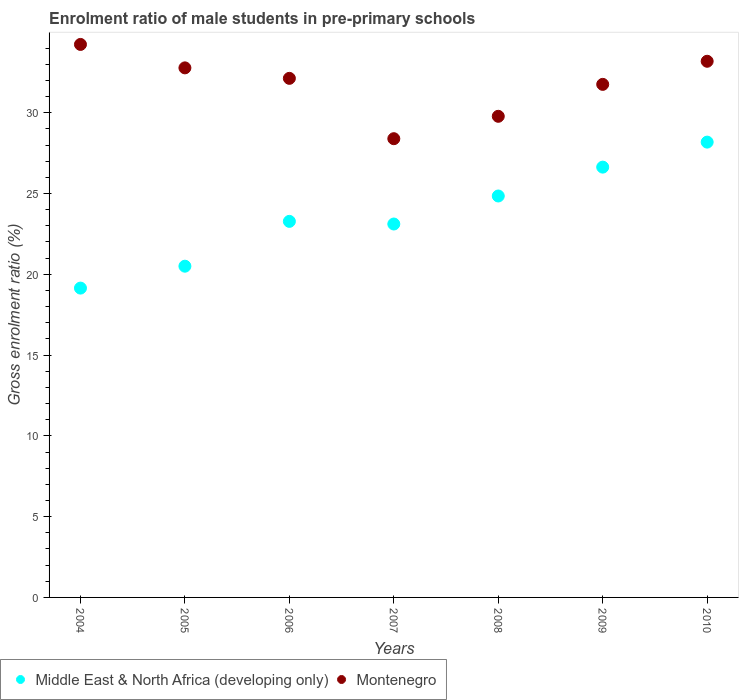How many different coloured dotlines are there?
Provide a short and direct response. 2. What is the enrolment ratio of male students in pre-primary schools in Montenegro in 2006?
Give a very brief answer. 32.13. Across all years, what is the maximum enrolment ratio of male students in pre-primary schools in Middle East & North Africa (developing only)?
Provide a short and direct response. 28.18. Across all years, what is the minimum enrolment ratio of male students in pre-primary schools in Middle East & North Africa (developing only)?
Your answer should be compact. 19.15. What is the total enrolment ratio of male students in pre-primary schools in Montenegro in the graph?
Your answer should be very brief. 222.25. What is the difference between the enrolment ratio of male students in pre-primary schools in Middle East & North Africa (developing only) in 2005 and that in 2009?
Make the answer very short. -6.13. What is the difference between the enrolment ratio of male students in pre-primary schools in Montenegro in 2007 and the enrolment ratio of male students in pre-primary schools in Middle East & North Africa (developing only) in 2010?
Give a very brief answer. 0.21. What is the average enrolment ratio of male students in pre-primary schools in Montenegro per year?
Offer a very short reply. 31.75. In the year 2009, what is the difference between the enrolment ratio of male students in pre-primary schools in Montenegro and enrolment ratio of male students in pre-primary schools in Middle East & North Africa (developing only)?
Offer a very short reply. 5.12. In how many years, is the enrolment ratio of male students in pre-primary schools in Montenegro greater than 27 %?
Offer a very short reply. 7. What is the ratio of the enrolment ratio of male students in pre-primary schools in Montenegro in 2005 to that in 2010?
Offer a terse response. 0.99. What is the difference between the highest and the second highest enrolment ratio of male students in pre-primary schools in Montenegro?
Make the answer very short. 1.04. What is the difference between the highest and the lowest enrolment ratio of male students in pre-primary schools in Middle East & North Africa (developing only)?
Offer a terse response. 9.04. In how many years, is the enrolment ratio of male students in pre-primary schools in Middle East & North Africa (developing only) greater than the average enrolment ratio of male students in pre-primary schools in Middle East & North Africa (developing only) taken over all years?
Your answer should be very brief. 3. Is the sum of the enrolment ratio of male students in pre-primary schools in Montenegro in 2005 and 2006 greater than the maximum enrolment ratio of male students in pre-primary schools in Middle East & North Africa (developing only) across all years?
Offer a terse response. Yes. Does the enrolment ratio of male students in pre-primary schools in Middle East & North Africa (developing only) monotonically increase over the years?
Provide a short and direct response. No. Is the enrolment ratio of male students in pre-primary schools in Montenegro strictly greater than the enrolment ratio of male students in pre-primary schools in Middle East & North Africa (developing only) over the years?
Offer a terse response. Yes. How many dotlines are there?
Your response must be concise. 2. How many years are there in the graph?
Give a very brief answer. 7. What is the difference between two consecutive major ticks on the Y-axis?
Make the answer very short. 5. Are the values on the major ticks of Y-axis written in scientific E-notation?
Give a very brief answer. No. Where does the legend appear in the graph?
Your response must be concise. Bottom left. How many legend labels are there?
Keep it short and to the point. 2. What is the title of the graph?
Provide a short and direct response. Enrolment ratio of male students in pre-primary schools. Does "China" appear as one of the legend labels in the graph?
Ensure brevity in your answer.  No. What is the label or title of the X-axis?
Ensure brevity in your answer.  Years. What is the label or title of the Y-axis?
Offer a very short reply. Gross enrolment ratio (%). What is the Gross enrolment ratio (%) of Middle East & North Africa (developing only) in 2004?
Make the answer very short. 19.15. What is the Gross enrolment ratio (%) in Montenegro in 2004?
Your response must be concise. 34.23. What is the Gross enrolment ratio (%) of Middle East & North Africa (developing only) in 2005?
Give a very brief answer. 20.5. What is the Gross enrolment ratio (%) of Montenegro in 2005?
Your answer should be compact. 32.78. What is the Gross enrolment ratio (%) in Middle East & North Africa (developing only) in 2006?
Provide a short and direct response. 23.28. What is the Gross enrolment ratio (%) in Montenegro in 2006?
Ensure brevity in your answer.  32.13. What is the Gross enrolment ratio (%) of Middle East & North Africa (developing only) in 2007?
Ensure brevity in your answer.  23.11. What is the Gross enrolment ratio (%) in Montenegro in 2007?
Keep it short and to the point. 28.39. What is the Gross enrolment ratio (%) of Middle East & North Africa (developing only) in 2008?
Ensure brevity in your answer.  24.85. What is the Gross enrolment ratio (%) in Montenegro in 2008?
Provide a succinct answer. 29.78. What is the Gross enrolment ratio (%) of Middle East & North Africa (developing only) in 2009?
Your answer should be compact. 26.63. What is the Gross enrolment ratio (%) of Montenegro in 2009?
Your response must be concise. 31.76. What is the Gross enrolment ratio (%) of Middle East & North Africa (developing only) in 2010?
Your response must be concise. 28.18. What is the Gross enrolment ratio (%) of Montenegro in 2010?
Make the answer very short. 33.19. Across all years, what is the maximum Gross enrolment ratio (%) in Middle East & North Africa (developing only)?
Your response must be concise. 28.18. Across all years, what is the maximum Gross enrolment ratio (%) in Montenegro?
Offer a terse response. 34.23. Across all years, what is the minimum Gross enrolment ratio (%) in Middle East & North Africa (developing only)?
Your response must be concise. 19.15. Across all years, what is the minimum Gross enrolment ratio (%) in Montenegro?
Give a very brief answer. 28.39. What is the total Gross enrolment ratio (%) in Middle East & North Africa (developing only) in the graph?
Provide a short and direct response. 165.7. What is the total Gross enrolment ratio (%) in Montenegro in the graph?
Offer a terse response. 222.25. What is the difference between the Gross enrolment ratio (%) in Middle East & North Africa (developing only) in 2004 and that in 2005?
Provide a short and direct response. -1.36. What is the difference between the Gross enrolment ratio (%) of Montenegro in 2004 and that in 2005?
Your response must be concise. 1.45. What is the difference between the Gross enrolment ratio (%) in Middle East & North Africa (developing only) in 2004 and that in 2006?
Make the answer very short. -4.13. What is the difference between the Gross enrolment ratio (%) in Montenegro in 2004 and that in 2006?
Your response must be concise. 2.1. What is the difference between the Gross enrolment ratio (%) in Middle East & North Africa (developing only) in 2004 and that in 2007?
Provide a short and direct response. -3.97. What is the difference between the Gross enrolment ratio (%) in Montenegro in 2004 and that in 2007?
Provide a succinct answer. 5.83. What is the difference between the Gross enrolment ratio (%) of Middle East & North Africa (developing only) in 2004 and that in 2008?
Offer a terse response. -5.7. What is the difference between the Gross enrolment ratio (%) in Montenegro in 2004 and that in 2008?
Make the answer very short. 4.45. What is the difference between the Gross enrolment ratio (%) of Middle East & North Africa (developing only) in 2004 and that in 2009?
Offer a very short reply. -7.49. What is the difference between the Gross enrolment ratio (%) of Montenegro in 2004 and that in 2009?
Make the answer very short. 2.47. What is the difference between the Gross enrolment ratio (%) in Middle East & North Africa (developing only) in 2004 and that in 2010?
Ensure brevity in your answer.  -9.04. What is the difference between the Gross enrolment ratio (%) in Montenegro in 2004 and that in 2010?
Offer a terse response. 1.04. What is the difference between the Gross enrolment ratio (%) in Middle East & North Africa (developing only) in 2005 and that in 2006?
Your answer should be compact. -2.77. What is the difference between the Gross enrolment ratio (%) in Montenegro in 2005 and that in 2006?
Your answer should be compact. 0.65. What is the difference between the Gross enrolment ratio (%) of Middle East & North Africa (developing only) in 2005 and that in 2007?
Provide a short and direct response. -2.61. What is the difference between the Gross enrolment ratio (%) of Montenegro in 2005 and that in 2007?
Provide a short and direct response. 4.38. What is the difference between the Gross enrolment ratio (%) of Middle East & North Africa (developing only) in 2005 and that in 2008?
Your response must be concise. -4.34. What is the difference between the Gross enrolment ratio (%) of Montenegro in 2005 and that in 2008?
Provide a short and direct response. 3. What is the difference between the Gross enrolment ratio (%) of Middle East & North Africa (developing only) in 2005 and that in 2009?
Your response must be concise. -6.13. What is the difference between the Gross enrolment ratio (%) in Montenegro in 2005 and that in 2009?
Ensure brevity in your answer.  1.02. What is the difference between the Gross enrolment ratio (%) of Middle East & North Africa (developing only) in 2005 and that in 2010?
Ensure brevity in your answer.  -7.68. What is the difference between the Gross enrolment ratio (%) in Montenegro in 2005 and that in 2010?
Give a very brief answer. -0.41. What is the difference between the Gross enrolment ratio (%) of Middle East & North Africa (developing only) in 2006 and that in 2007?
Your answer should be compact. 0.16. What is the difference between the Gross enrolment ratio (%) of Montenegro in 2006 and that in 2007?
Make the answer very short. 3.74. What is the difference between the Gross enrolment ratio (%) in Middle East & North Africa (developing only) in 2006 and that in 2008?
Make the answer very short. -1.57. What is the difference between the Gross enrolment ratio (%) of Montenegro in 2006 and that in 2008?
Give a very brief answer. 2.35. What is the difference between the Gross enrolment ratio (%) in Middle East & North Africa (developing only) in 2006 and that in 2009?
Keep it short and to the point. -3.36. What is the difference between the Gross enrolment ratio (%) in Montenegro in 2006 and that in 2009?
Your answer should be very brief. 0.37. What is the difference between the Gross enrolment ratio (%) of Middle East & North Africa (developing only) in 2006 and that in 2010?
Your response must be concise. -4.91. What is the difference between the Gross enrolment ratio (%) of Montenegro in 2006 and that in 2010?
Offer a terse response. -1.06. What is the difference between the Gross enrolment ratio (%) in Middle East & North Africa (developing only) in 2007 and that in 2008?
Your response must be concise. -1.73. What is the difference between the Gross enrolment ratio (%) in Montenegro in 2007 and that in 2008?
Your response must be concise. -1.39. What is the difference between the Gross enrolment ratio (%) of Middle East & North Africa (developing only) in 2007 and that in 2009?
Offer a terse response. -3.52. What is the difference between the Gross enrolment ratio (%) of Montenegro in 2007 and that in 2009?
Ensure brevity in your answer.  -3.36. What is the difference between the Gross enrolment ratio (%) in Middle East & North Africa (developing only) in 2007 and that in 2010?
Offer a terse response. -5.07. What is the difference between the Gross enrolment ratio (%) in Montenegro in 2007 and that in 2010?
Your response must be concise. -4.79. What is the difference between the Gross enrolment ratio (%) of Middle East & North Africa (developing only) in 2008 and that in 2009?
Ensure brevity in your answer.  -1.79. What is the difference between the Gross enrolment ratio (%) in Montenegro in 2008 and that in 2009?
Your answer should be compact. -1.98. What is the difference between the Gross enrolment ratio (%) of Middle East & North Africa (developing only) in 2008 and that in 2010?
Provide a succinct answer. -3.34. What is the difference between the Gross enrolment ratio (%) in Montenegro in 2008 and that in 2010?
Give a very brief answer. -3.41. What is the difference between the Gross enrolment ratio (%) of Middle East & North Africa (developing only) in 2009 and that in 2010?
Your answer should be compact. -1.55. What is the difference between the Gross enrolment ratio (%) in Montenegro in 2009 and that in 2010?
Your response must be concise. -1.43. What is the difference between the Gross enrolment ratio (%) in Middle East & North Africa (developing only) in 2004 and the Gross enrolment ratio (%) in Montenegro in 2005?
Your answer should be compact. -13.63. What is the difference between the Gross enrolment ratio (%) in Middle East & North Africa (developing only) in 2004 and the Gross enrolment ratio (%) in Montenegro in 2006?
Your answer should be compact. -12.98. What is the difference between the Gross enrolment ratio (%) of Middle East & North Africa (developing only) in 2004 and the Gross enrolment ratio (%) of Montenegro in 2007?
Give a very brief answer. -9.25. What is the difference between the Gross enrolment ratio (%) in Middle East & North Africa (developing only) in 2004 and the Gross enrolment ratio (%) in Montenegro in 2008?
Ensure brevity in your answer.  -10.63. What is the difference between the Gross enrolment ratio (%) in Middle East & North Africa (developing only) in 2004 and the Gross enrolment ratio (%) in Montenegro in 2009?
Make the answer very short. -12.61. What is the difference between the Gross enrolment ratio (%) of Middle East & North Africa (developing only) in 2004 and the Gross enrolment ratio (%) of Montenegro in 2010?
Your answer should be very brief. -14.04. What is the difference between the Gross enrolment ratio (%) of Middle East & North Africa (developing only) in 2005 and the Gross enrolment ratio (%) of Montenegro in 2006?
Make the answer very short. -11.63. What is the difference between the Gross enrolment ratio (%) of Middle East & North Africa (developing only) in 2005 and the Gross enrolment ratio (%) of Montenegro in 2007?
Make the answer very short. -7.89. What is the difference between the Gross enrolment ratio (%) in Middle East & North Africa (developing only) in 2005 and the Gross enrolment ratio (%) in Montenegro in 2008?
Your answer should be very brief. -9.28. What is the difference between the Gross enrolment ratio (%) in Middle East & North Africa (developing only) in 2005 and the Gross enrolment ratio (%) in Montenegro in 2009?
Offer a very short reply. -11.25. What is the difference between the Gross enrolment ratio (%) of Middle East & North Africa (developing only) in 2005 and the Gross enrolment ratio (%) of Montenegro in 2010?
Offer a terse response. -12.68. What is the difference between the Gross enrolment ratio (%) of Middle East & North Africa (developing only) in 2006 and the Gross enrolment ratio (%) of Montenegro in 2007?
Offer a very short reply. -5.12. What is the difference between the Gross enrolment ratio (%) in Middle East & North Africa (developing only) in 2006 and the Gross enrolment ratio (%) in Montenegro in 2008?
Provide a short and direct response. -6.5. What is the difference between the Gross enrolment ratio (%) of Middle East & North Africa (developing only) in 2006 and the Gross enrolment ratio (%) of Montenegro in 2009?
Provide a short and direct response. -8.48. What is the difference between the Gross enrolment ratio (%) in Middle East & North Africa (developing only) in 2006 and the Gross enrolment ratio (%) in Montenegro in 2010?
Your response must be concise. -9.91. What is the difference between the Gross enrolment ratio (%) of Middle East & North Africa (developing only) in 2007 and the Gross enrolment ratio (%) of Montenegro in 2008?
Make the answer very short. -6.67. What is the difference between the Gross enrolment ratio (%) in Middle East & North Africa (developing only) in 2007 and the Gross enrolment ratio (%) in Montenegro in 2009?
Provide a succinct answer. -8.64. What is the difference between the Gross enrolment ratio (%) of Middle East & North Africa (developing only) in 2007 and the Gross enrolment ratio (%) of Montenegro in 2010?
Provide a succinct answer. -10.07. What is the difference between the Gross enrolment ratio (%) of Middle East & North Africa (developing only) in 2008 and the Gross enrolment ratio (%) of Montenegro in 2009?
Give a very brief answer. -6.91. What is the difference between the Gross enrolment ratio (%) of Middle East & North Africa (developing only) in 2008 and the Gross enrolment ratio (%) of Montenegro in 2010?
Your answer should be very brief. -8.34. What is the difference between the Gross enrolment ratio (%) of Middle East & North Africa (developing only) in 2009 and the Gross enrolment ratio (%) of Montenegro in 2010?
Your answer should be compact. -6.55. What is the average Gross enrolment ratio (%) of Middle East & North Africa (developing only) per year?
Provide a short and direct response. 23.67. What is the average Gross enrolment ratio (%) in Montenegro per year?
Make the answer very short. 31.75. In the year 2004, what is the difference between the Gross enrolment ratio (%) in Middle East & North Africa (developing only) and Gross enrolment ratio (%) in Montenegro?
Provide a short and direct response. -15.08. In the year 2005, what is the difference between the Gross enrolment ratio (%) of Middle East & North Africa (developing only) and Gross enrolment ratio (%) of Montenegro?
Keep it short and to the point. -12.28. In the year 2006, what is the difference between the Gross enrolment ratio (%) of Middle East & North Africa (developing only) and Gross enrolment ratio (%) of Montenegro?
Provide a short and direct response. -8.85. In the year 2007, what is the difference between the Gross enrolment ratio (%) of Middle East & North Africa (developing only) and Gross enrolment ratio (%) of Montenegro?
Your answer should be compact. -5.28. In the year 2008, what is the difference between the Gross enrolment ratio (%) of Middle East & North Africa (developing only) and Gross enrolment ratio (%) of Montenegro?
Make the answer very short. -4.93. In the year 2009, what is the difference between the Gross enrolment ratio (%) of Middle East & North Africa (developing only) and Gross enrolment ratio (%) of Montenegro?
Your answer should be very brief. -5.12. In the year 2010, what is the difference between the Gross enrolment ratio (%) of Middle East & North Africa (developing only) and Gross enrolment ratio (%) of Montenegro?
Offer a terse response. -5. What is the ratio of the Gross enrolment ratio (%) of Middle East & North Africa (developing only) in 2004 to that in 2005?
Provide a succinct answer. 0.93. What is the ratio of the Gross enrolment ratio (%) of Montenegro in 2004 to that in 2005?
Give a very brief answer. 1.04. What is the ratio of the Gross enrolment ratio (%) in Middle East & North Africa (developing only) in 2004 to that in 2006?
Offer a terse response. 0.82. What is the ratio of the Gross enrolment ratio (%) of Montenegro in 2004 to that in 2006?
Your answer should be compact. 1.07. What is the ratio of the Gross enrolment ratio (%) in Middle East & North Africa (developing only) in 2004 to that in 2007?
Give a very brief answer. 0.83. What is the ratio of the Gross enrolment ratio (%) in Montenegro in 2004 to that in 2007?
Your response must be concise. 1.21. What is the ratio of the Gross enrolment ratio (%) in Middle East & North Africa (developing only) in 2004 to that in 2008?
Provide a short and direct response. 0.77. What is the ratio of the Gross enrolment ratio (%) in Montenegro in 2004 to that in 2008?
Provide a short and direct response. 1.15. What is the ratio of the Gross enrolment ratio (%) of Middle East & North Africa (developing only) in 2004 to that in 2009?
Keep it short and to the point. 0.72. What is the ratio of the Gross enrolment ratio (%) in Montenegro in 2004 to that in 2009?
Provide a short and direct response. 1.08. What is the ratio of the Gross enrolment ratio (%) in Middle East & North Africa (developing only) in 2004 to that in 2010?
Your answer should be compact. 0.68. What is the ratio of the Gross enrolment ratio (%) of Montenegro in 2004 to that in 2010?
Ensure brevity in your answer.  1.03. What is the ratio of the Gross enrolment ratio (%) in Middle East & North Africa (developing only) in 2005 to that in 2006?
Your response must be concise. 0.88. What is the ratio of the Gross enrolment ratio (%) in Montenegro in 2005 to that in 2006?
Offer a terse response. 1.02. What is the ratio of the Gross enrolment ratio (%) in Middle East & North Africa (developing only) in 2005 to that in 2007?
Ensure brevity in your answer.  0.89. What is the ratio of the Gross enrolment ratio (%) in Montenegro in 2005 to that in 2007?
Your answer should be compact. 1.15. What is the ratio of the Gross enrolment ratio (%) of Middle East & North Africa (developing only) in 2005 to that in 2008?
Provide a short and direct response. 0.83. What is the ratio of the Gross enrolment ratio (%) of Montenegro in 2005 to that in 2008?
Give a very brief answer. 1.1. What is the ratio of the Gross enrolment ratio (%) in Middle East & North Africa (developing only) in 2005 to that in 2009?
Offer a very short reply. 0.77. What is the ratio of the Gross enrolment ratio (%) in Montenegro in 2005 to that in 2009?
Your answer should be compact. 1.03. What is the ratio of the Gross enrolment ratio (%) of Middle East & North Africa (developing only) in 2005 to that in 2010?
Make the answer very short. 0.73. What is the ratio of the Gross enrolment ratio (%) of Middle East & North Africa (developing only) in 2006 to that in 2007?
Your answer should be compact. 1.01. What is the ratio of the Gross enrolment ratio (%) of Montenegro in 2006 to that in 2007?
Offer a terse response. 1.13. What is the ratio of the Gross enrolment ratio (%) of Middle East & North Africa (developing only) in 2006 to that in 2008?
Make the answer very short. 0.94. What is the ratio of the Gross enrolment ratio (%) in Montenegro in 2006 to that in 2008?
Make the answer very short. 1.08. What is the ratio of the Gross enrolment ratio (%) of Middle East & North Africa (developing only) in 2006 to that in 2009?
Your answer should be very brief. 0.87. What is the ratio of the Gross enrolment ratio (%) in Montenegro in 2006 to that in 2009?
Your answer should be compact. 1.01. What is the ratio of the Gross enrolment ratio (%) of Middle East & North Africa (developing only) in 2006 to that in 2010?
Provide a succinct answer. 0.83. What is the ratio of the Gross enrolment ratio (%) of Montenegro in 2006 to that in 2010?
Your answer should be very brief. 0.97. What is the ratio of the Gross enrolment ratio (%) of Middle East & North Africa (developing only) in 2007 to that in 2008?
Provide a short and direct response. 0.93. What is the ratio of the Gross enrolment ratio (%) of Montenegro in 2007 to that in 2008?
Offer a terse response. 0.95. What is the ratio of the Gross enrolment ratio (%) of Middle East & North Africa (developing only) in 2007 to that in 2009?
Offer a terse response. 0.87. What is the ratio of the Gross enrolment ratio (%) in Montenegro in 2007 to that in 2009?
Keep it short and to the point. 0.89. What is the ratio of the Gross enrolment ratio (%) in Middle East & North Africa (developing only) in 2007 to that in 2010?
Provide a succinct answer. 0.82. What is the ratio of the Gross enrolment ratio (%) in Montenegro in 2007 to that in 2010?
Make the answer very short. 0.86. What is the ratio of the Gross enrolment ratio (%) in Middle East & North Africa (developing only) in 2008 to that in 2009?
Give a very brief answer. 0.93. What is the ratio of the Gross enrolment ratio (%) in Montenegro in 2008 to that in 2009?
Provide a short and direct response. 0.94. What is the ratio of the Gross enrolment ratio (%) of Middle East & North Africa (developing only) in 2008 to that in 2010?
Offer a terse response. 0.88. What is the ratio of the Gross enrolment ratio (%) of Montenegro in 2008 to that in 2010?
Your answer should be very brief. 0.9. What is the ratio of the Gross enrolment ratio (%) in Middle East & North Africa (developing only) in 2009 to that in 2010?
Provide a short and direct response. 0.95. What is the ratio of the Gross enrolment ratio (%) in Montenegro in 2009 to that in 2010?
Offer a terse response. 0.96. What is the difference between the highest and the second highest Gross enrolment ratio (%) of Middle East & North Africa (developing only)?
Your response must be concise. 1.55. What is the difference between the highest and the second highest Gross enrolment ratio (%) of Montenegro?
Your answer should be very brief. 1.04. What is the difference between the highest and the lowest Gross enrolment ratio (%) of Middle East & North Africa (developing only)?
Make the answer very short. 9.04. What is the difference between the highest and the lowest Gross enrolment ratio (%) of Montenegro?
Offer a very short reply. 5.83. 